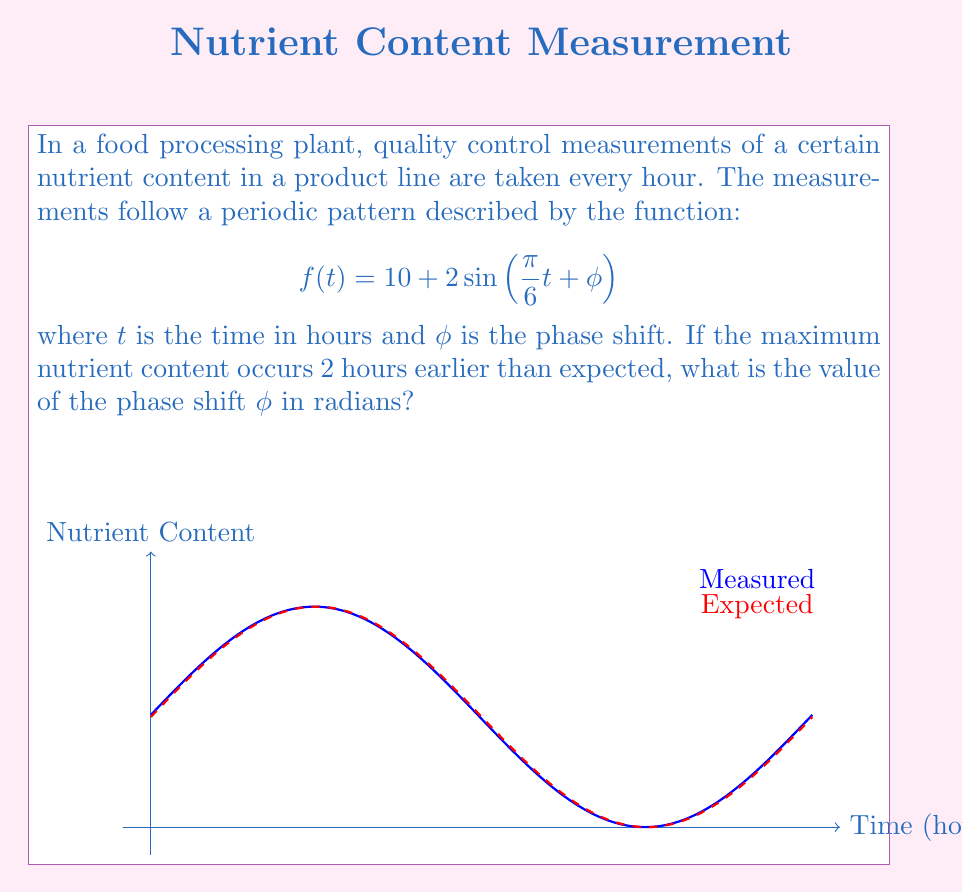Teach me how to tackle this problem. To solve this problem, we need to follow these steps:

1) In a sine function $A\sin(\omega t + \phi)$, the phase shift is represented by $-\frac{\phi}{\omega}$.

2) In our case, $\omega = \frac{\pi}{6}$, so the phase shift in terms of time is $-\frac{6\phi}{\pi}$ hours.

3) We're told that the maximum occurs 2 hours earlier than expected, so:

   $$-\frac{6\phi}{\pi} = -2$$

4) Solving for $\phi$:

   $$\phi = \frac{\pi}{3}$$

5) To verify: 
   - The original function would have maxima at $t = 3, 15, 27, ...$ (when $\frac{\pi}{6}t = \frac{\pi}{2}, \frac{5\pi}{2}, \frac{9\pi}{2}, ...$)
   - With $\phi = \frac{\pi}{3}$, maxima occur at $t = 1, 13, 25, ...$ (when $\frac{\pi}{6}t + \frac{\pi}{3} = \frac{\pi}{2}, \frac{5\pi}{2}, \frac{9\pi}{2}, ...$)

This confirms that the maxima occur 2 hours earlier with this phase shift.
Answer: $\frac{\pi}{3}$ radians 